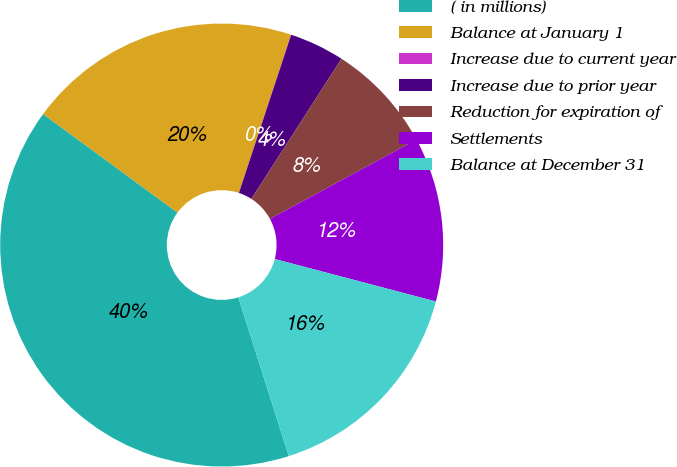<chart> <loc_0><loc_0><loc_500><loc_500><pie_chart><fcel>( in millions)<fcel>Balance at January 1<fcel>Increase due to current year<fcel>Increase due to prior year<fcel>Reduction for expiration of<fcel>Settlements<fcel>Balance at December 31<nl><fcel>39.97%<fcel>19.99%<fcel>0.02%<fcel>4.01%<fcel>8.01%<fcel>12.0%<fcel>16.0%<nl></chart> 